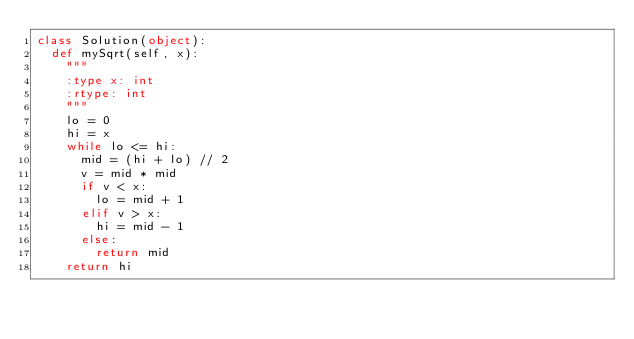Convert code to text. <code><loc_0><loc_0><loc_500><loc_500><_Python_>class Solution(object):
  def mySqrt(self, x):
    """
    :type x: int
    :rtype: int
    """
    lo = 0
    hi = x
    while lo <= hi:
      mid = (hi + lo) // 2
      v = mid * mid
      if v < x:
        lo = mid + 1
      elif v > x:
        hi = mid - 1
      else:
        return mid
    return hi</code> 